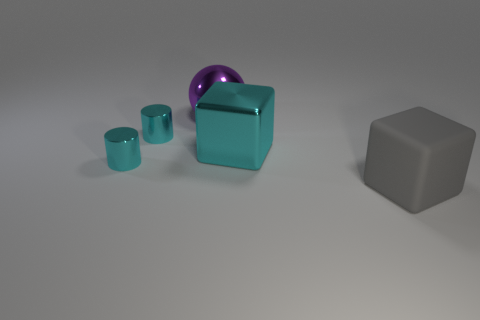Can you describe the lighting in the scene? The lighting in the scene appears to be diffused, with soft shadows cast by the objects. This indicates an ambient light source, possibly overhead, that illuminates the entire setup without creating harsh direct light or deep shadows. 